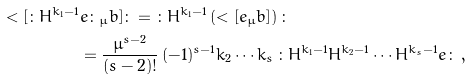Convert formula to latex. <formula><loc_0><loc_0><loc_500><loc_500>< [ { \colon } H ^ { k _ { 1 } - 1 } & e { \colon } _ { \mu } b ] { \colon } = { \colon } H ^ { k _ { 1 } - 1 } \left ( < [ e _ { \mu } b ] \right ) { \colon } \\ & = \frac { \mu ^ { s - 2 } } { ( s - 2 ) ! } \, ( - 1 ) ^ { s - 1 } k _ { 2 } \cdots k _ { s } \, { \colon } H ^ { k _ { 1 } - 1 } H ^ { k _ { 2 } - 1 } \cdots H ^ { k _ { s } - 1 } e { \colon } \, ,</formula> 